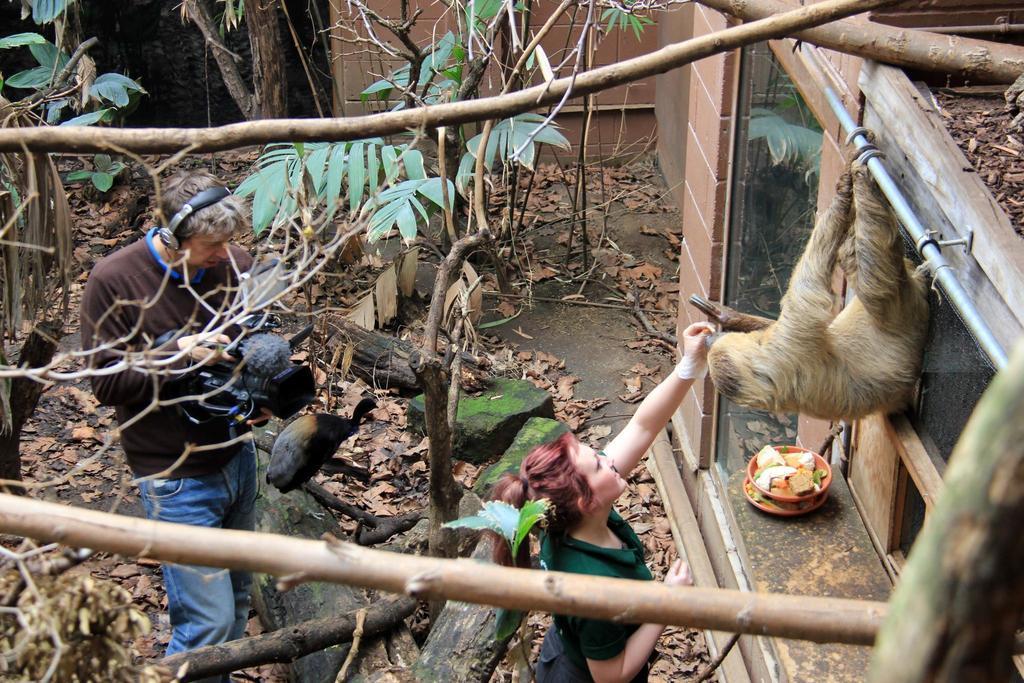Can you describe this image briefly? In this image we can see there is a monkey hanging to the rod of a building, in front of the monkey there is a lady and she is placing her hand towards the monkey, back of this lady there is a person taking the picture of a bird, which is on the tree. There are some dry leaves on the floor. 